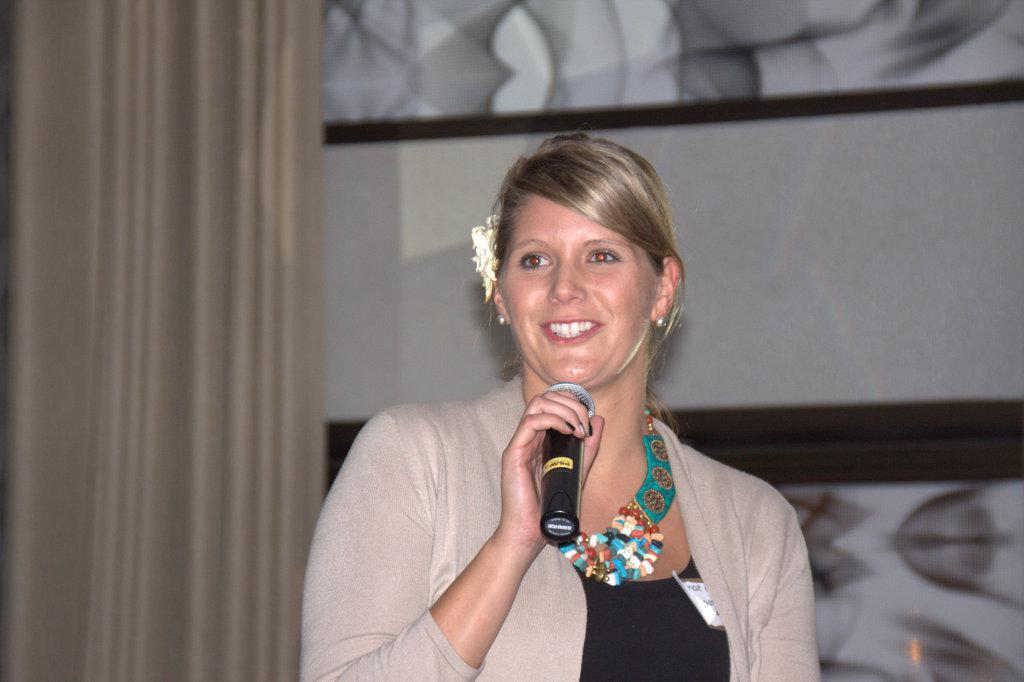Who is the main subject in the image? There is a lady standing in the center of the image. What is the lady holding in the image? The lady is holding a mic. What can be seen on the left side of the image? There is a curtain on the left side of the image. What is visible in the background of the image? There is a wall visible in the background of the image. What color is the arch in the image? There is no arch present in the image. 